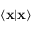Convert formula to latex. <formula><loc_0><loc_0><loc_500><loc_500>\langle x | x \rangle</formula> 